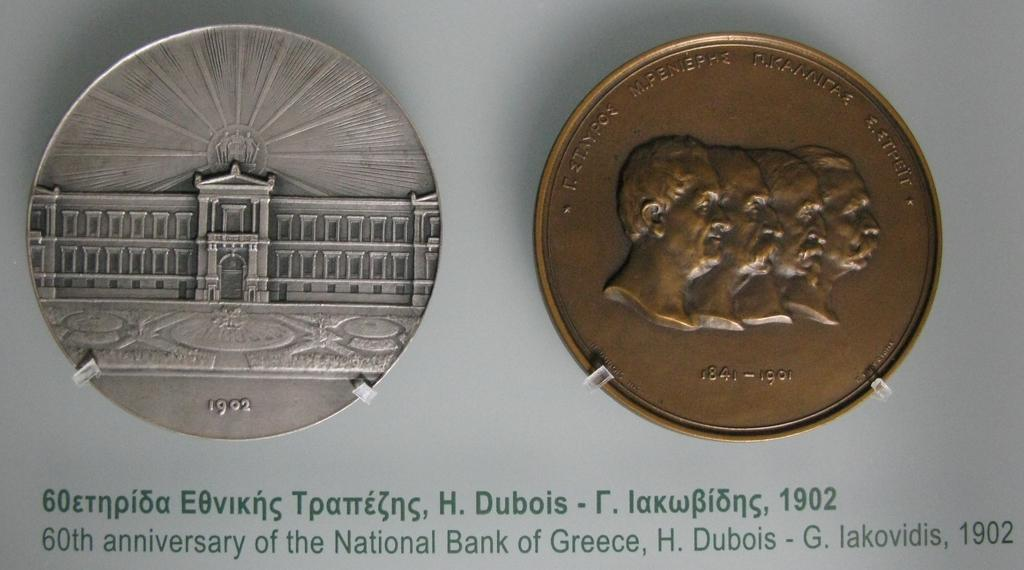<image>
Provide a brief description of the given image. Silver coin from 1902 next to a copper coin from 1841-1901 